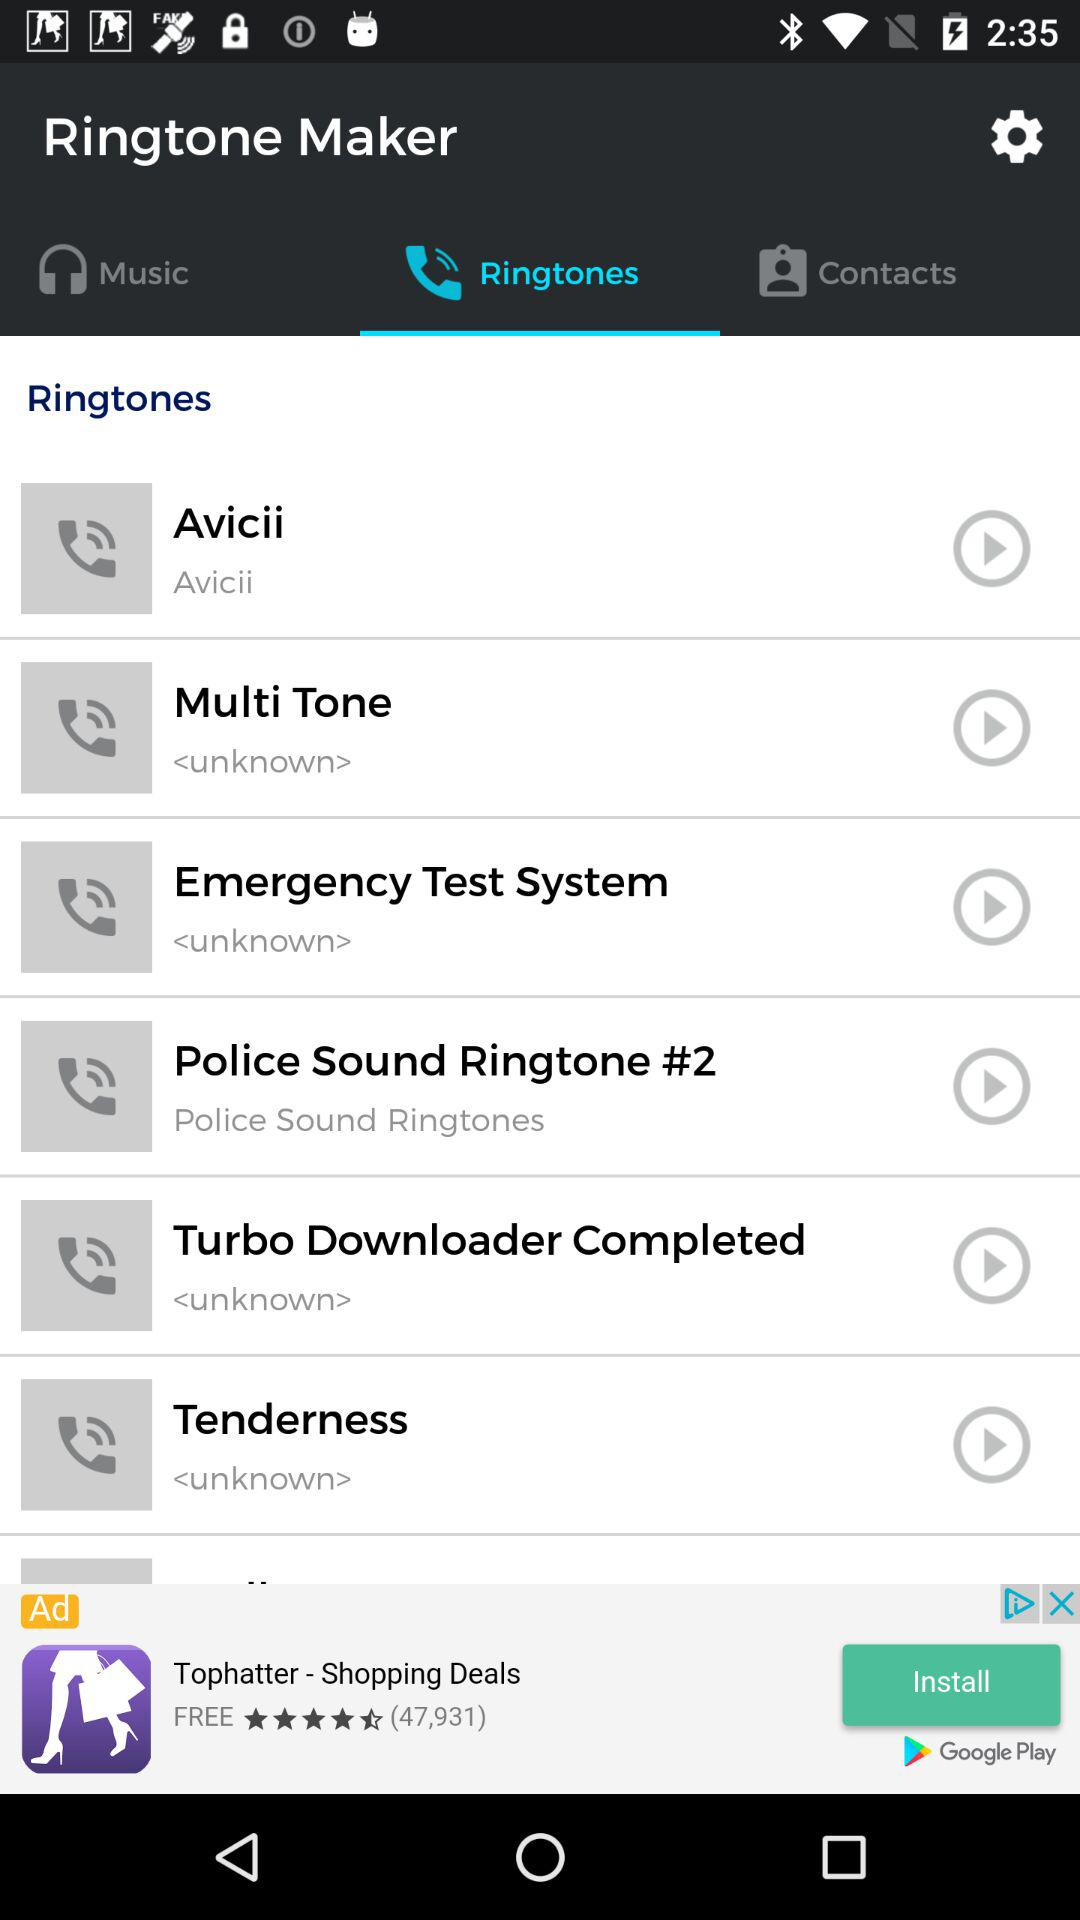How many ringtones are by Avicii?
Answer the question using a single word or phrase. 1 